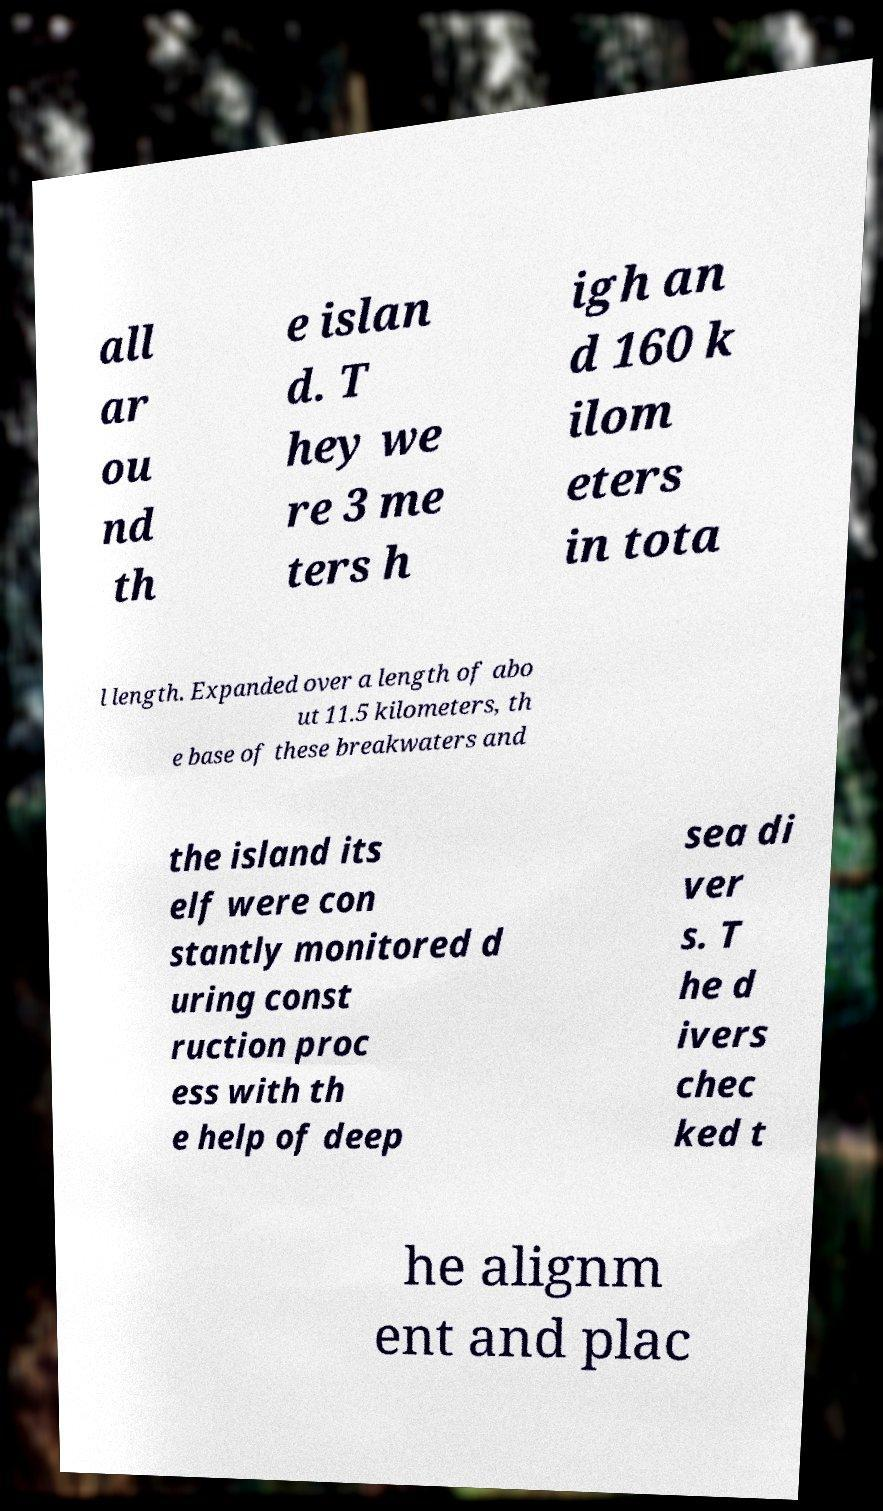Could you assist in decoding the text presented in this image and type it out clearly? all ar ou nd th e islan d. T hey we re 3 me ters h igh an d 160 k ilom eters in tota l length. Expanded over a length of abo ut 11.5 kilometers, th e base of these breakwaters and the island its elf were con stantly monitored d uring const ruction proc ess with th e help of deep sea di ver s. T he d ivers chec ked t he alignm ent and plac 